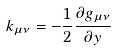Convert formula to latex. <formula><loc_0><loc_0><loc_500><loc_500>k _ { \mu \nu } = - \frac { 1 } { 2 } \frac { \partial g _ { \mu \nu } } { \partial y }</formula> 